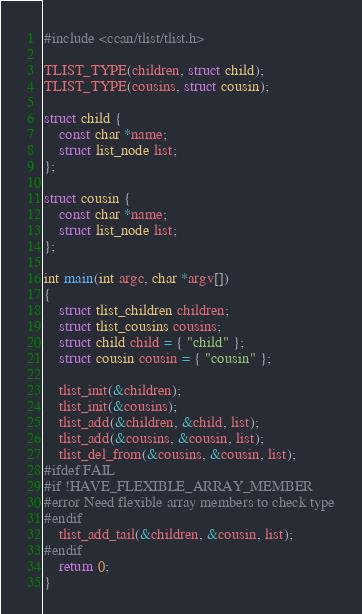<code> <loc_0><loc_0><loc_500><loc_500><_C_>#include <ccan/tlist/tlist.h>

TLIST_TYPE(children, struct child);
TLIST_TYPE(cousins, struct cousin);

struct child {
	const char *name;
	struct list_node list;
};

struct cousin {
	const char *name;
	struct list_node list;
};

int main(int argc, char *argv[])
{
	struct tlist_children children;
	struct tlist_cousins cousins;
	struct child child = { "child" };
	struct cousin cousin = { "cousin" };

	tlist_init(&children);
	tlist_init(&cousins);
	tlist_add(&children, &child, list);
	tlist_add(&cousins, &cousin, list);
	tlist_del_from(&cousins, &cousin, list);
#ifdef FAIL
#if !HAVE_FLEXIBLE_ARRAY_MEMBER
#error Need flexible array members to check type
#endif
	tlist_add_tail(&children, &cousin, list);
#endif
	return 0;
}
</code> 